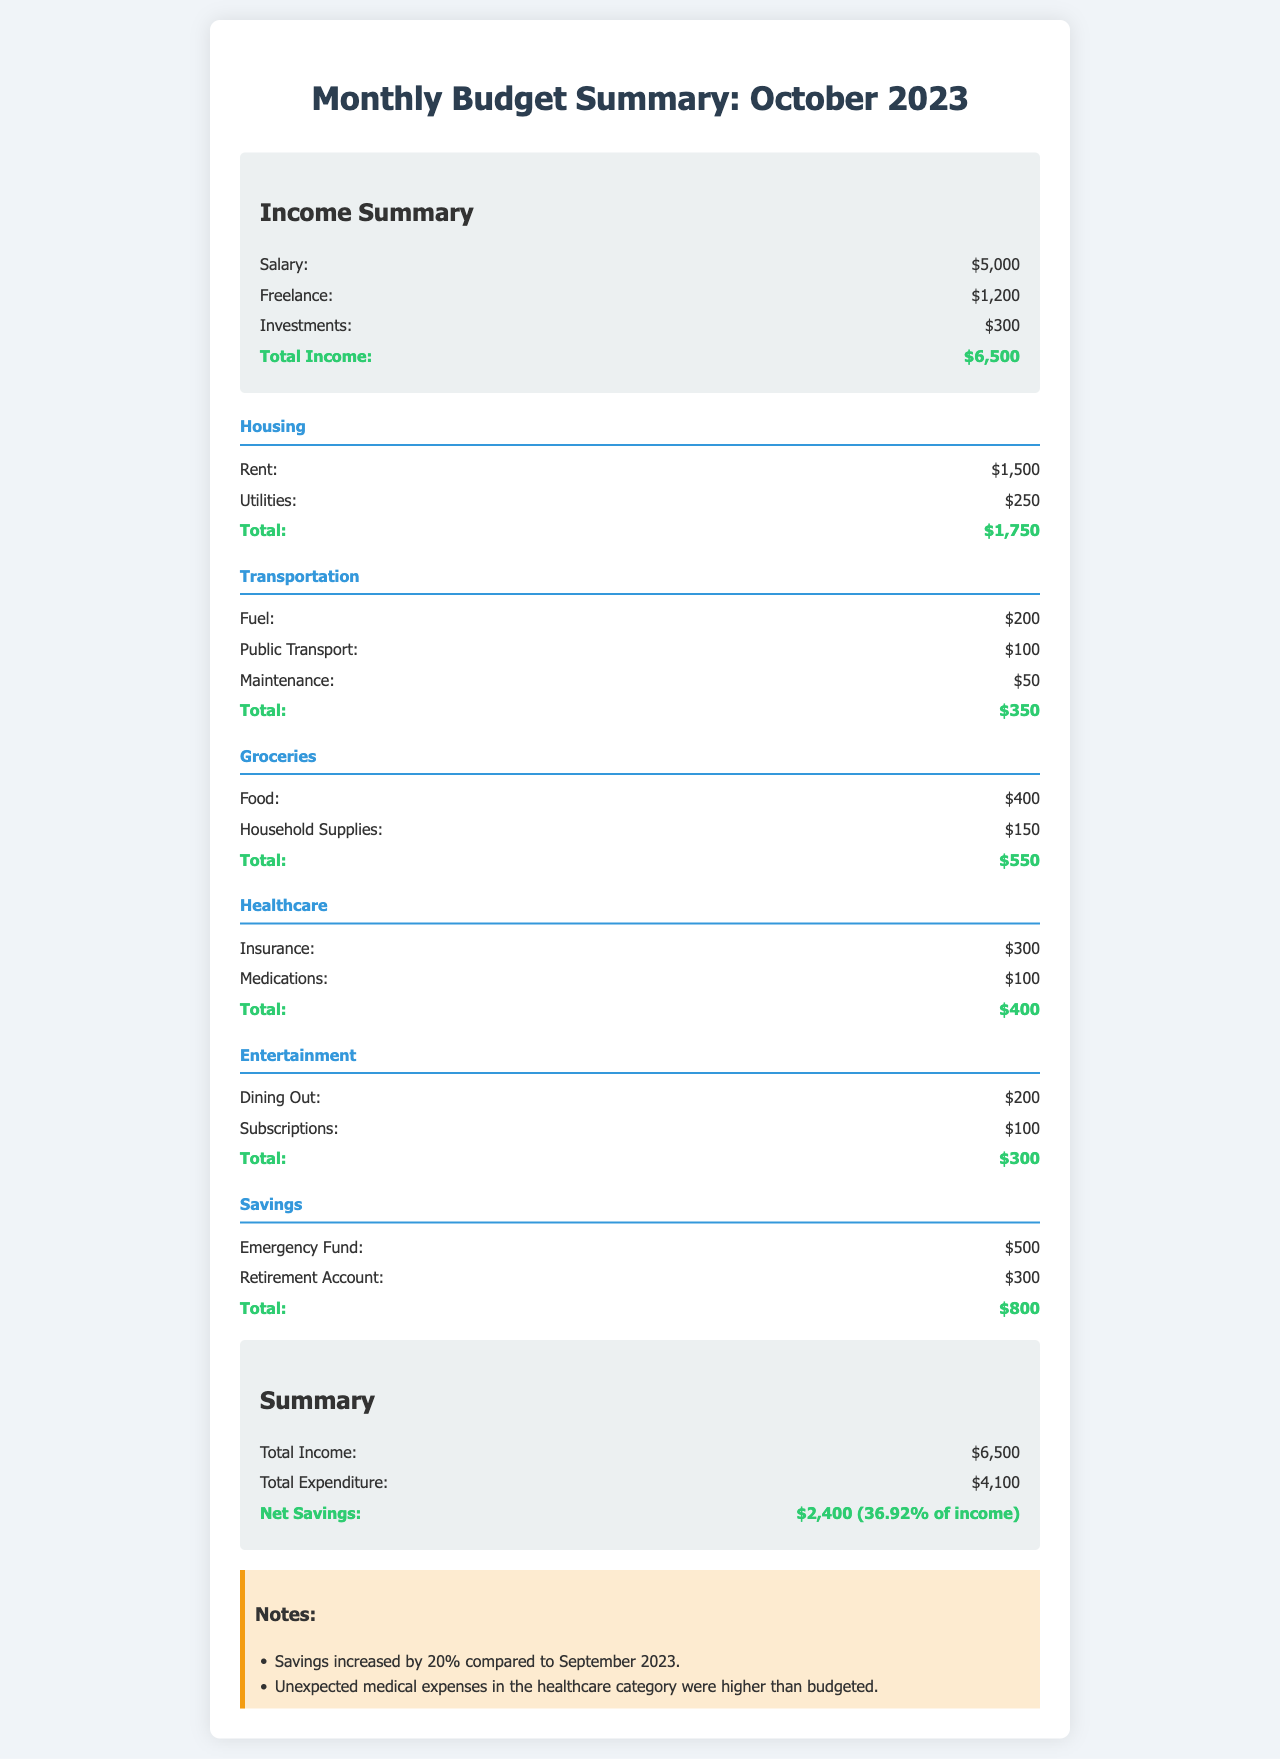What is the total income for October 2023? The total income is the sum of all income categories: Salary, Freelance, and Investments, which equals $5,000 + $1,200 + $300.
Answer: $6,500 What was spent on groceries? The total expenditure on groceries is calculated from Food and Household Supplies, which is $400 + $150.
Answer: $550 How much was allocated to entertainment? The spending on entertainment includes Dining Out and Subscriptions, totaling $200 + $100.
Answer: $300 What is the total expenditure for October 2023? The total expenditure is presented as the sum of all categories: Housing, Transportation, Groceries, Healthcare, Entertainment, and Savings, which adds up to $4,100.
Answer: $4,100 How much did the emergency fund increase compared to September 2023? There is a note stating that savings increased by 20% compared to the previous month, referring specifically to savings in total.
Answer: 20% What is the amount listed for net savings? Net savings is the difference between total income and total expenditure, shown directly in the summary section as $6,500 - $4,100.
Answer: $2,400 What was the highest category of expenditure? By comparing all total expenditures of each category, Housing costs $1,750, which is the highest.
Answer: Housing How much was spent on healthcare overall? The total healthcare expenditure includes Insurance and Medications, which sums to $300 + $100.
Answer: $400 What percentage of income constitutes net savings? The document states that net savings are $2,400 which is 36.92% of the total income, calculated as (Net Savings / Total Income) * 100.
Answer: 36.92% 